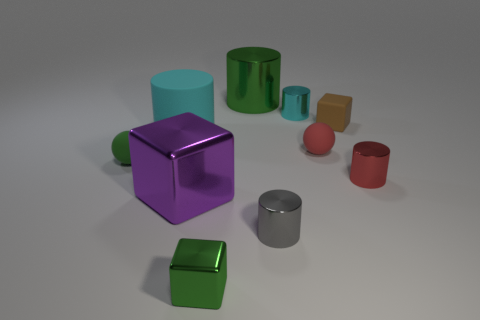Subtract all brown cylinders. Subtract all gray spheres. How many cylinders are left? 5 Subtract all cubes. How many objects are left? 7 Add 6 small brown shiny cubes. How many small brown shiny cubes exist? 6 Subtract 0 blue blocks. How many objects are left? 10 Subtract all matte cylinders. Subtract all green cubes. How many objects are left? 8 Add 8 small green shiny objects. How many small green shiny objects are left? 9 